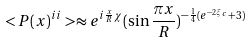Convert formula to latex. <formula><loc_0><loc_0><loc_500><loc_500>< P ( x ) ^ { i i } > \approx e ^ { i { \frac { x } { R } } \chi } ( \sin { \frac { \pi x } { R } } ) ^ { - { \frac { 1 } { 4 } } ( e ^ { - 2 \xi _ { c } } + 3 ) }</formula> 